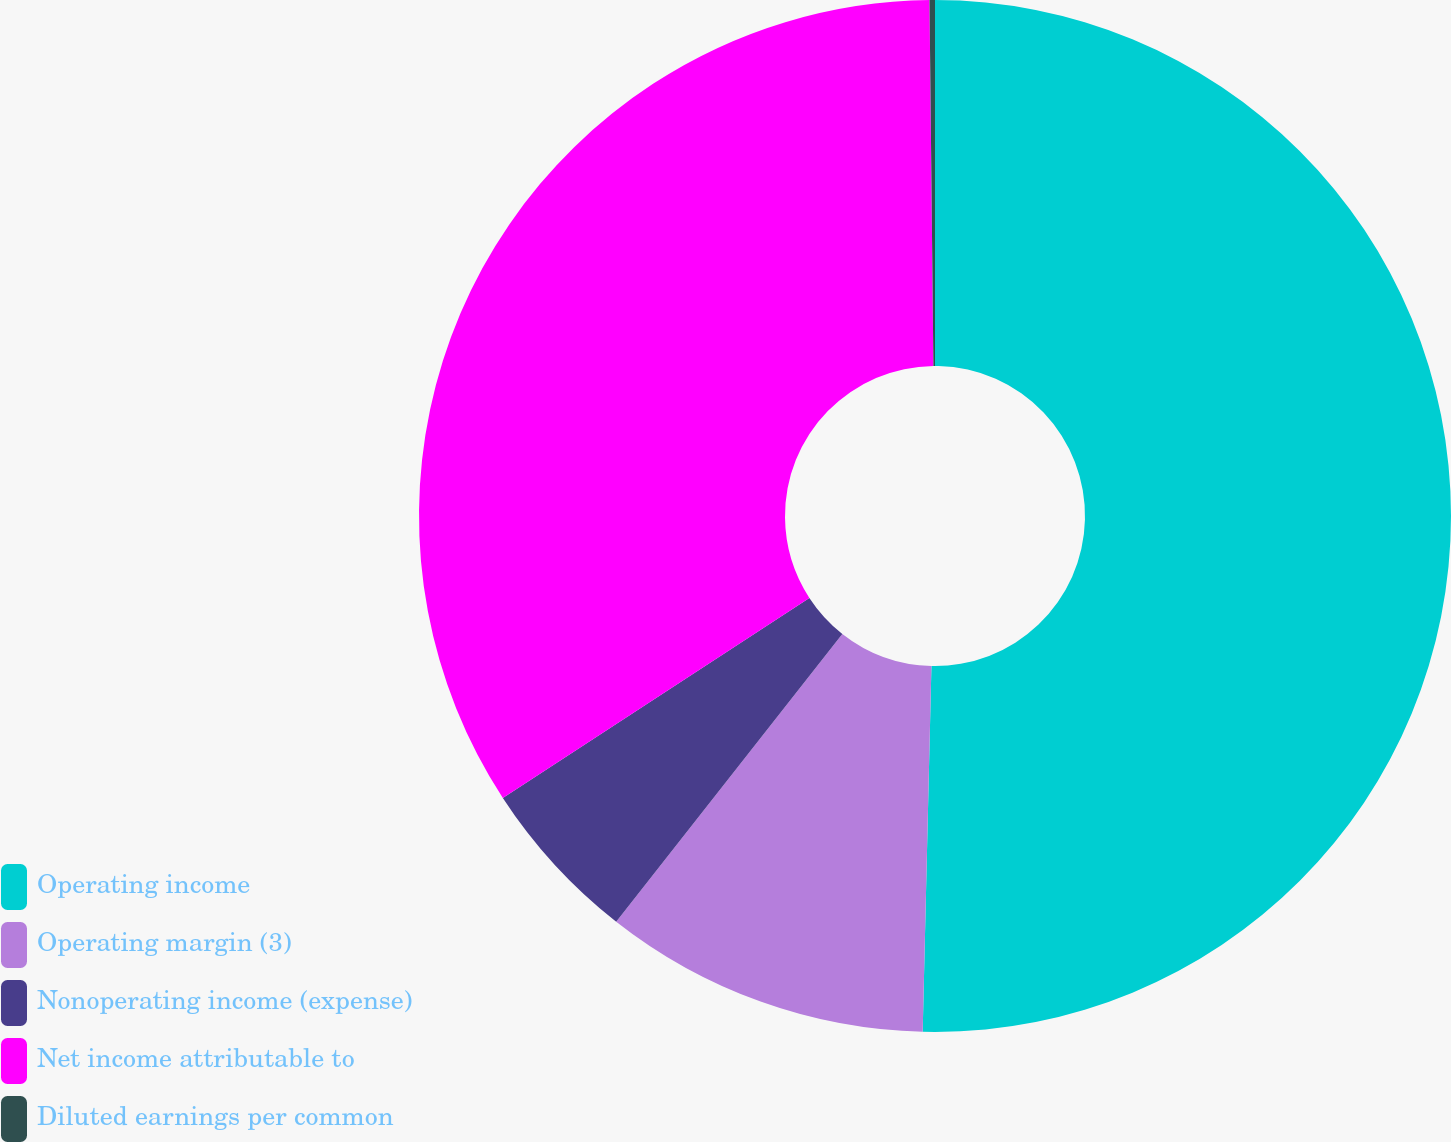<chart> <loc_0><loc_0><loc_500><loc_500><pie_chart><fcel>Operating income<fcel>Operating margin (3)<fcel>Nonoperating income (expense)<fcel>Net income attributable to<fcel>Diluted earnings per common<nl><fcel>50.38%<fcel>10.22%<fcel>5.2%<fcel>34.03%<fcel>0.17%<nl></chart> 